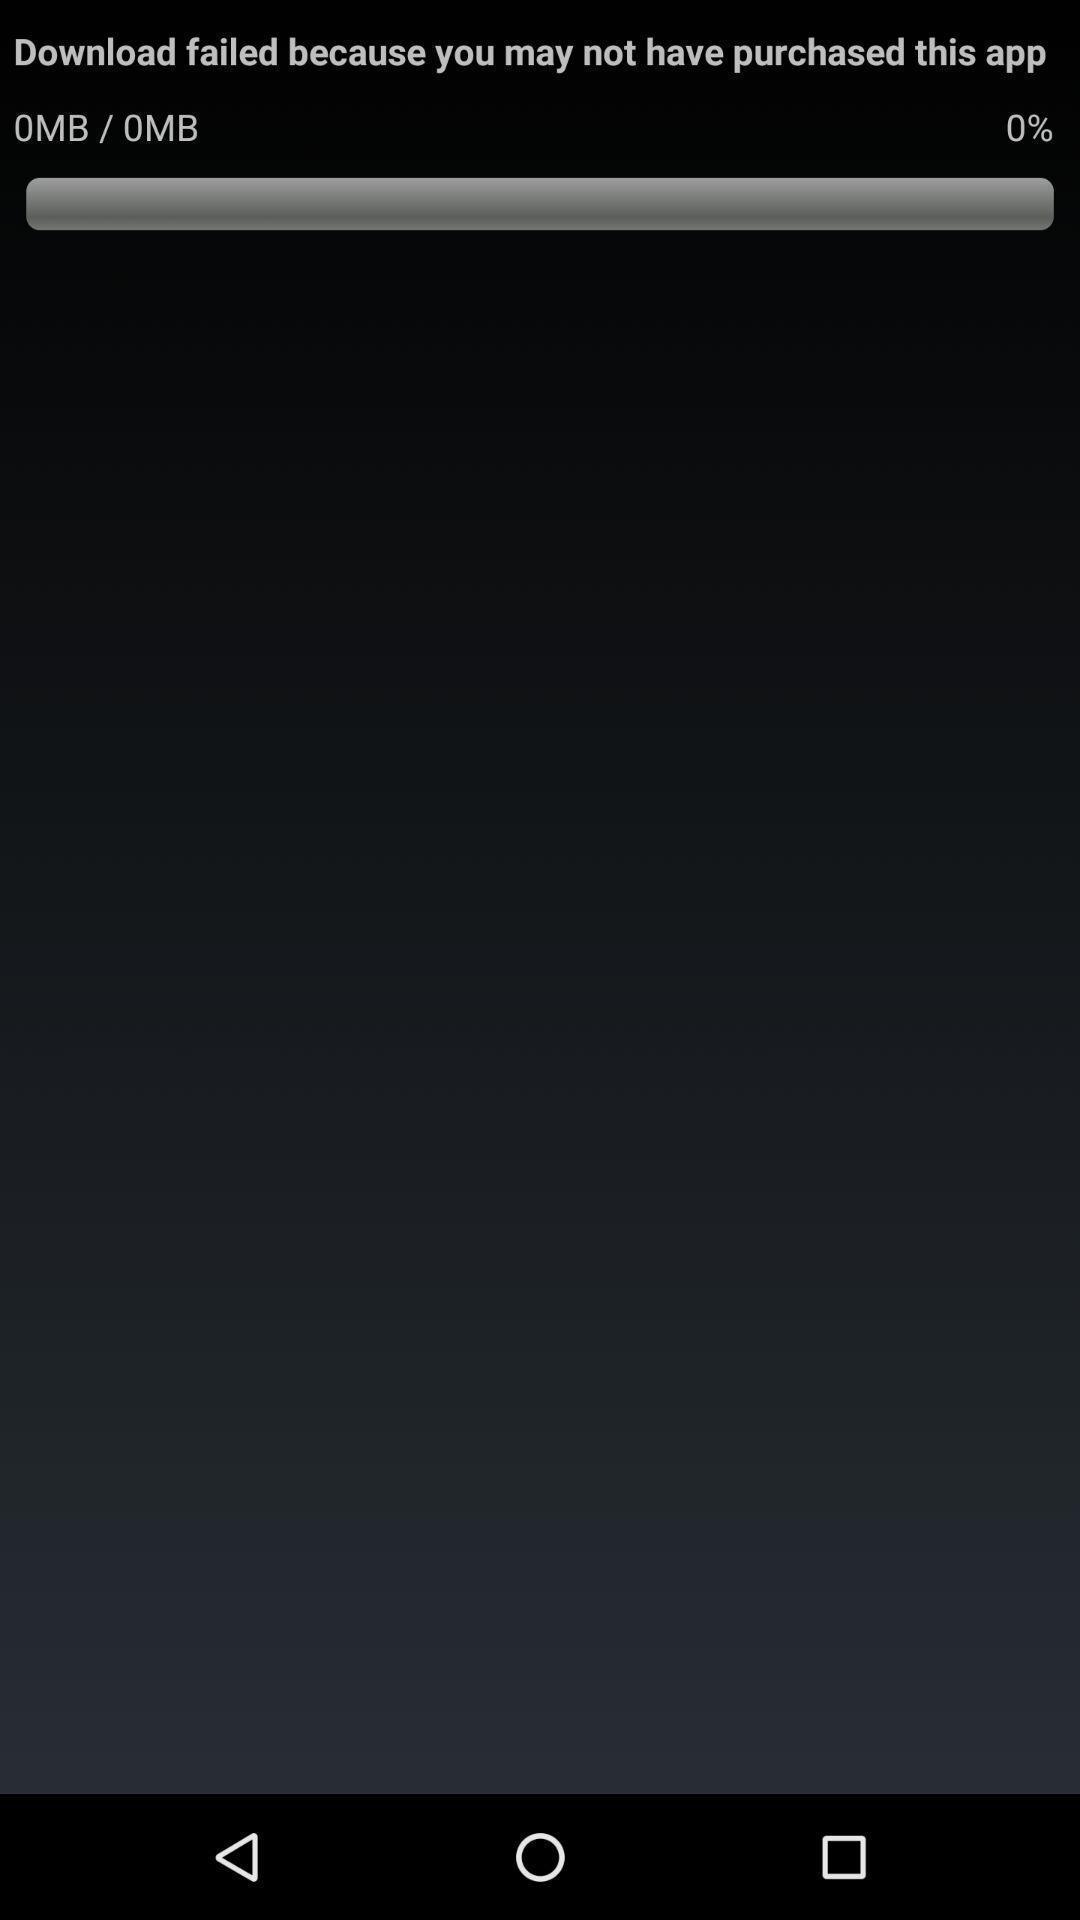Explain the elements present in this screenshot. Screen displaying application download information. 